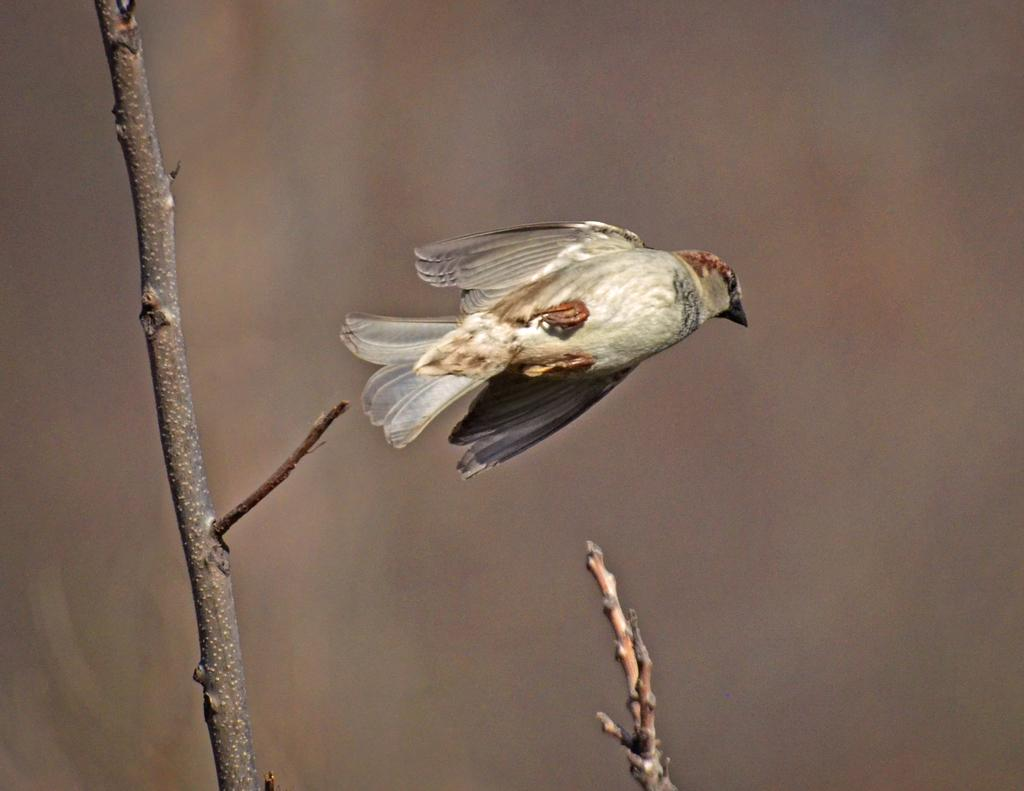What is the main subject of the image? The main subject of the image is a bird flying in the air. What objects can be seen in addition to the bird? There are wooden sticks visible in the image. Can you describe the background of the image? The background of the image is blurry. What type of tail can be seen on the vessel in the image? There is no vessel present in the image, and therefore no tail can be seen. 